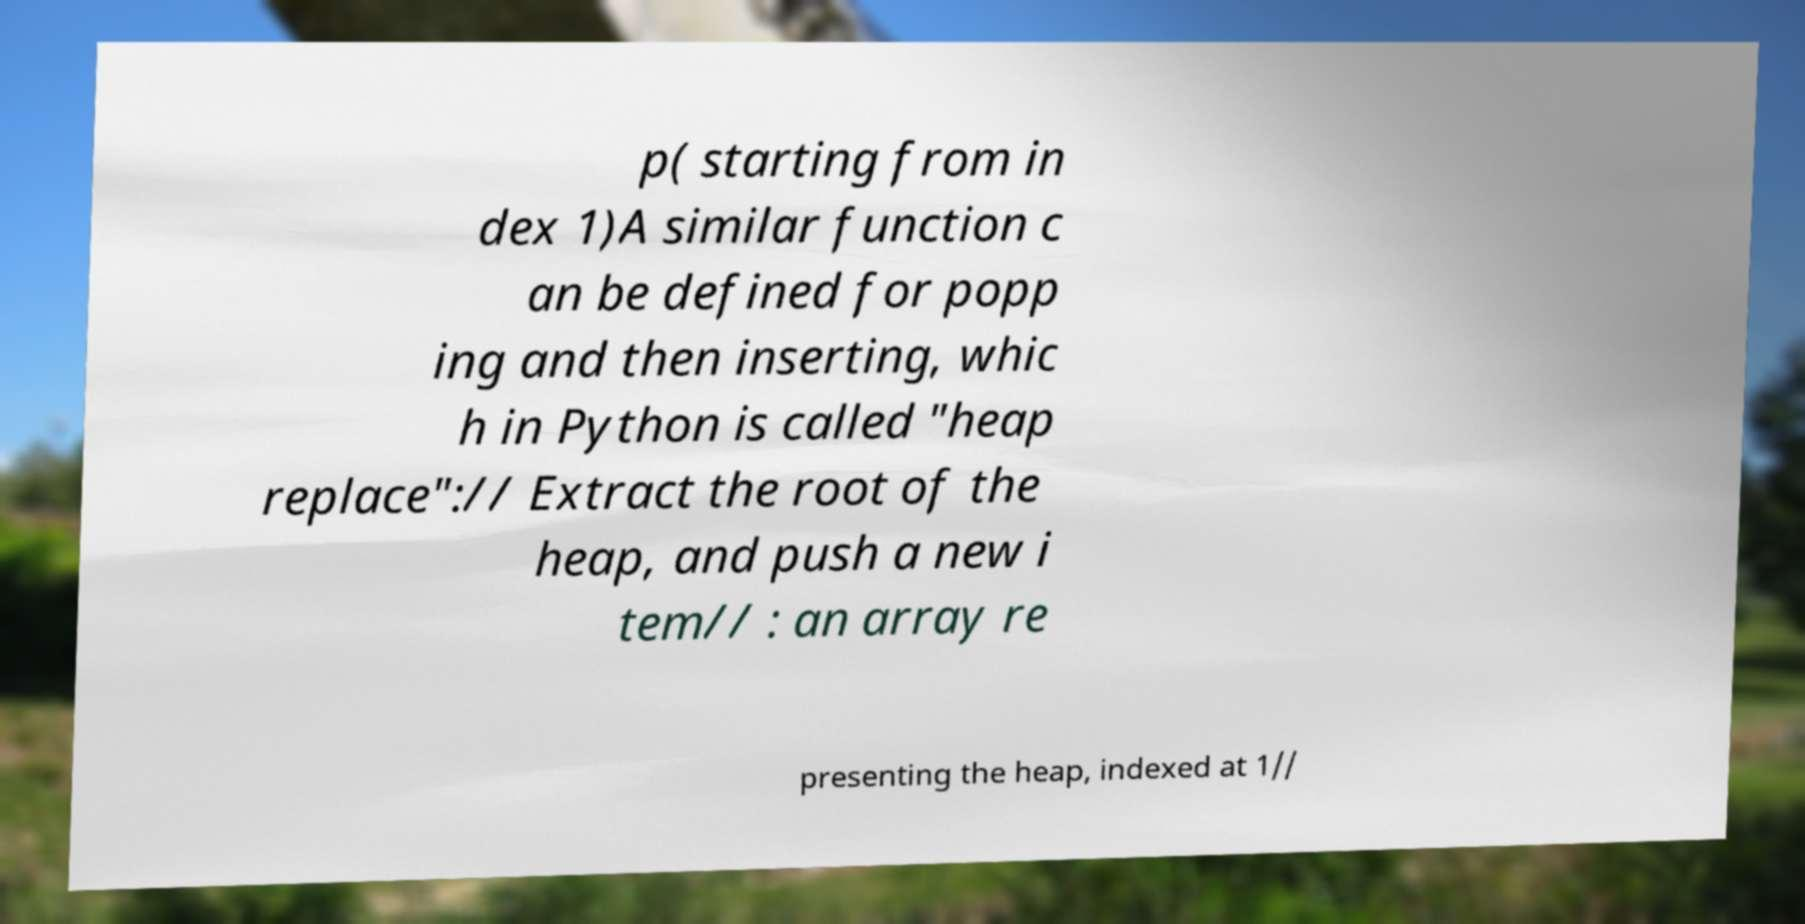I need the written content from this picture converted into text. Can you do that? p( starting from in dex 1)A similar function c an be defined for popp ing and then inserting, whic h in Python is called "heap replace":// Extract the root of the heap, and push a new i tem// : an array re presenting the heap, indexed at 1// 